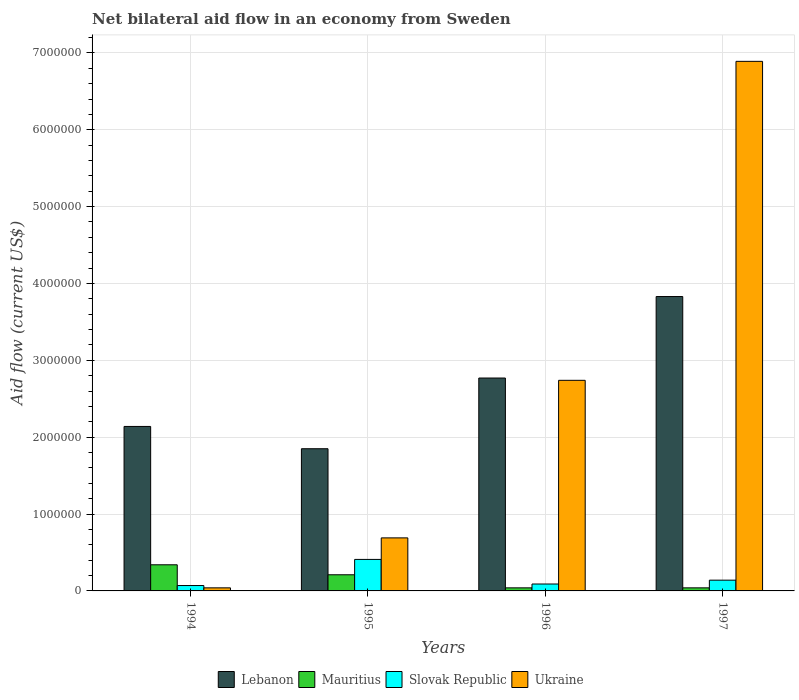Are the number of bars per tick equal to the number of legend labels?
Offer a terse response. Yes. What is the label of the 4th group of bars from the left?
Keep it short and to the point. 1997. In how many cases, is the number of bars for a given year not equal to the number of legend labels?
Your answer should be very brief. 0. Across all years, what is the maximum net bilateral aid flow in Slovak Republic?
Your answer should be very brief. 4.10e+05. In which year was the net bilateral aid flow in Ukraine maximum?
Give a very brief answer. 1997. In which year was the net bilateral aid flow in Mauritius minimum?
Provide a succinct answer. 1996. What is the total net bilateral aid flow in Lebanon in the graph?
Your response must be concise. 1.06e+07. What is the difference between the net bilateral aid flow in Slovak Republic in 1995 and that in 1996?
Your answer should be very brief. 3.20e+05. What is the difference between the net bilateral aid flow in Lebanon in 1994 and the net bilateral aid flow in Ukraine in 1995?
Provide a succinct answer. 1.45e+06. What is the average net bilateral aid flow in Slovak Republic per year?
Give a very brief answer. 1.78e+05. In the year 1994, what is the difference between the net bilateral aid flow in Lebanon and net bilateral aid flow in Slovak Republic?
Keep it short and to the point. 2.07e+06. In how many years, is the net bilateral aid flow in Mauritius greater than 5000000 US$?
Keep it short and to the point. 0. What is the ratio of the net bilateral aid flow in Lebanon in 1994 to that in 1997?
Keep it short and to the point. 0.56. Is the difference between the net bilateral aid flow in Lebanon in 1995 and 1997 greater than the difference between the net bilateral aid flow in Slovak Republic in 1995 and 1997?
Your answer should be very brief. No. In how many years, is the net bilateral aid flow in Lebanon greater than the average net bilateral aid flow in Lebanon taken over all years?
Provide a short and direct response. 2. Is it the case that in every year, the sum of the net bilateral aid flow in Lebanon and net bilateral aid flow in Ukraine is greater than the sum of net bilateral aid flow in Mauritius and net bilateral aid flow in Slovak Republic?
Give a very brief answer. Yes. What does the 4th bar from the left in 1994 represents?
Offer a very short reply. Ukraine. What does the 3rd bar from the right in 1997 represents?
Offer a terse response. Mauritius. Are all the bars in the graph horizontal?
Keep it short and to the point. No. How many years are there in the graph?
Provide a short and direct response. 4. What is the difference between two consecutive major ticks on the Y-axis?
Your response must be concise. 1.00e+06. Does the graph contain any zero values?
Give a very brief answer. No. Does the graph contain grids?
Your answer should be compact. Yes. How many legend labels are there?
Make the answer very short. 4. What is the title of the graph?
Your answer should be very brief. Net bilateral aid flow in an economy from Sweden. What is the Aid flow (current US$) in Lebanon in 1994?
Ensure brevity in your answer.  2.14e+06. What is the Aid flow (current US$) in Mauritius in 1994?
Provide a succinct answer. 3.40e+05. What is the Aid flow (current US$) in Slovak Republic in 1994?
Ensure brevity in your answer.  7.00e+04. What is the Aid flow (current US$) of Ukraine in 1994?
Offer a very short reply. 4.00e+04. What is the Aid flow (current US$) in Lebanon in 1995?
Your answer should be very brief. 1.85e+06. What is the Aid flow (current US$) of Mauritius in 1995?
Offer a terse response. 2.10e+05. What is the Aid flow (current US$) in Slovak Republic in 1995?
Offer a very short reply. 4.10e+05. What is the Aid flow (current US$) of Ukraine in 1995?
Make the answer very short. 6.90e+05. What is the Aid flow (current US$) in Lebanon in 1996?
Give a very brief answer. 2.77e+06. What is the Aid flow (current US$) in Mauritius in 1996?
Ensure brevity in your answer.  4.00e+04. What is the Aid flow (current US$) of Slovak Republic in 1996?
Offer a very short reply. 9.00e+04. What is the Aid flow (current US$) in Ukraine in 1996?
Offer a very short reply. 2.74e+06. What is the Aid flow (current US$) of Lebanon in 1997?
Make the answer very short. 3.83e+06. What is the Aid flow (current US$) in Slovak Republic in 1997?
Provide a succinct answer. 1.40e+05. What is the Aid flow (current US$) in Ukraine in 1997?
Your answer should be very brief. 6.89e+06. Across all years, what is the maximum Aid flow (current US$) of Lebanon?
Provide a short and direct response. 3.83e+06. Across all years, what is the maximum Aid flow (current US$) in Mauritius?
Give a very brief answer. 3.40e+05. Across all years, what is the maximum Aid flow (current US$) of Ukraine?
Your response must be concise. 6.89e+06. Across all years, what is the minimum Aid flow (current US$) of Lebanon?
Offer a terse response. 1.85e+06. Across all years, what is the minimum Aid flow (current US$) in Mauritius?
Make the answer very short. 4.00e+04. Across all years, what is the minimum Aid flow (current US$) of Ukraine?
Ensure brevity in your answer.  4.00e+04. What is the total Aid flow (current US$) of Lebanon in the graph?
Your answer should be very brief. 1.06e+07. What is the total Aid flow (current US$) of Mauritius in the graph?
Your response must be concise. 6.30e+05. What is the total Aid flow (current US$) of Slovak Republic in the graph?
Keep it short and to the point. 7.10e+05. What is the total Aid flow (current US$) of Ukraine in the graph?
Offer a very short reply. 1.04e+07. What is the difference between the Aid flow (current US$) in Lebanon in 1994 and that in 1995?
Keep it short and to the point. 2.90e+05. What is the difference between the Aid flow (current US$) of Slovak Republic in 1994 and that in 1995?
Your response must be concise. -3.40e+05. What is the difference between the Aid flow (current US$) of Ukraine in 1994 and that in 1995?
Offer a terse response. -6.50e+05. What is the difference between the Aid flow (current US$) in Lebanon in 1994 and that in 1996?
Provide a succinct answer. -6.30e+05. What is the difference between the Aid flow (current US$) in Ukraine in 1994 and that in 1996?
Ensure brevity in your answer.  -2.70e+06. What is the difference between the Aid flow (current US$) in Lebanon in 1994 and that in 1997?
Give a very brief answer. -1.69e+06. What is the difference between the Aid flow (current US$) of Ukraine in 1994 and that in 1997?
Offer a terse response. -6.85e+06. What is the difference between the Aid flow (current US$) in Lebanon in 1995 and that in 1996?
Make the answer very short. -9.20e+05. What is the difference between the Aid flow (current US$) of Slovak Republic in 1995 and that in 1996?
Make the answer very short. 3.20e+05. What is the difference between the Aid flow (current US$) in Ukraine in 1995 and that in 1996?
Provide a short and direct response. -2.05e+06. What is the difference between the Aid flow (current US$) of Lebanon in 1995 and that in 1997?
Offer a very short reply. -1.98e+06. What is the difference between the Aid flow (current US$) of Ukraine in 1995 and that in 1997?
Give a very brief answer. -6.20e+06. What is the difference between the Aid flow (current US$) in Lebanon in 1996 and that in 1997?
Keep it short and to the point. -1.06e+06. What is the difference between the Aid flow (current US$) in Ukraine in 1996 and that in 1997?
Offer a very short reply. -4.15e+06. What is the difference between the Aid flow (current US$) of Lebanon in 1994 and the Aid flow (current US$) of Mauritius in 1995?
Offer a very short reply. 1.93e+06. What is the difference between the Aid flow (current US$) of Lebanon in 1994 and the Aid flow (current US$) of Slovak Republic in 1995?
Your answer should be very brief. 1.73e+06. What is the difference between the Aid flow (current US$) of Lebanon in 1994 and the Aid flow (current US$) of Ukraine in 1995?
Give a very brief answer. 1.45e+06. What is the difference between the Aid flow (current US$) of Mauritius in 1994 and the Aid flow (current US$) of Ukraine in 1995?
Offer a terse response. -3.50e+05. What is the difference between the Aid flow (current US$) in Slovak Republic in 1994 and the Aid flow (current US$) in Ukraine in 1995?
Your answer should be very brief. -6.20e+05. What is the difference between the Aid flow (current US$) in Lebanon in 1994 and the Aid flow (current US$) in Mauritius in 1996?
Keep it short and to the point. 2.10e+06. What is the difference between the Aid flow (current US$) of Lebanon in 1994 and the Aid flow (current US$) of Slovak Republic in 1996?
Offer a very short reply. 2.05e+06. What is the difference between the Aid flow (current US$) of Lebanon in 1994 and the Aid flow (current US$) of Ukraine in 1996?
Your answer should be compact. -6.00e+05. What is the difference between the Aid flow (current US$) of Mauritius in 1994 and the Aid flow (current US$) of Ukraine in 1996?
Provide a short and direct response. -2.40e+06. What is the difference between the Aid flow (current US$) of Slovak Republic in 1994 and the Aid flow (current US$) of Ukraine in 1996?
Provide a succinct answer. -2.67e+06. What is the difference between the Aid flow (current US$) of Lebanon in 1994 and the Aid flow (current US$) of Mauritius in 1997?
Offer a very short reply. 2.10e+06. What is the difference between the Aid flow (current US$) of Lebanon in 1994 and the Aid flow (current US$) of Ukraine in 1997?
Offer a very short reply. -4.75e+06. What is the difference between the Aid flow (current US$) of Mauritius in 1994 and the Aid flow (current US$) of Slovak Republic in 1997?
Your answer should be compact. 2.00e+05. What is the difference between the Aid flow (current US$) in Mauritius in 1994 and the Aid flow (current US$) in Ukraine in 1997?
Offer a very short reply. -6.55e+06. What is the difference between the Aid flow (current US$) in Slovak Republic in 1994 and the Aid flow (current US$) in Ukraine in 1997?
Give a very brief answer. -6.82e+06. What is the difference between the Aid flow (current US$) of Lebanon in 1995 and the Aid flow (current US$) of Mauritius in 1996?
Your response must be concise. 1.81e+06. What is the difference between the Aid flow (current US$) in Lebanon in 1995 and the Aid flow (current US$) in Slovak Republic in 1996?
Provide a short and direct response. 1.76e+06. What is the difference between the Aid flow (current US$) in Lebanon in 1995 and the Aid flow (current US$) in Ukraine in 1996?
Offer a terse response. -8.90e+05. What is the difference between the Aid flow (current US$) in Mauritius in 1995 and the Aid flow (current US$) in Ukraine in 1996?
Your answer should be very brief. -2.53e+06. What is the difference between the Aid flow (current US$) of Slovak Republic in 1995 and the Aid flow (current US$) of Ukraine in 1996?
Offer a very short reply. -2.33e+06. What is the difference between the Aid flow (current US$) of Lebanon in 1995 and the Aid flow (current US$) of Mauritius in 1997?
Provide a succinct answer. 1.81e+06. What is the difference between the Aid flow (current US$) in Lebanon in 1995 and the Aid flow (current US$) in Slovak Republic in 1997?
Ensure brevity in your answer.  1.71e+06. What is the difference between the Aid flow (current US$) in Lebanon in 1995 and the Aid flow (current US$) in Ukraine in 1997?
Keep it short and to the point. -5.04e+06. What is the difference between the Aid flow (current US$) in Mauritius in 1995 and the Aid flow (current US$) in Slovak Republic in 1997?
Your response must be concise. 7.00e+04. What is the difference between the Aid flow (current US$) in Mauritius in 1995 and the Aid flow (current US$) in Ukraine in 1997?
Provide a short and direct response. -6.68e+06. What is the difference between the Aid flow (current US$) in Slovak Republic in 1995 and the Aid flow (current US$) in Ukraine in 1997?
Your answer should be very brief. -6.48e+06. What is the difference between the Aid flow (current US$) in Lebanon in 1996 and the Aid flow (current US$) in Mauritius in 1997?
Your answer should be compact. 2.73e+06. What is the difference between the Aid flow (current US$) in Lebanon in 1996 and the Aid flow (current US$) in Slovak Republic in 1997?
Keep it short and to the point. 2.63e+06. What is the difference between the Aid flow (current US$) of Lebanon in 1996 and the Aid flow (current US$) of Ukraine in 1997?
Ensure brevity in your answer.  -4.12e+06. What is the difference between the Aid flow (current US$) of Mauritius in 1996 and the Aid flow (current US$) of Slovak Republic in 1997?
Your answer should be compact. -1.00e+05. What is the difference between the Aid flow (current US$) of Mauritius in 1996 and the Aid flow (current US$) of Ukraine in 1997?
Your answer should be very brief. -6.85e+06. What is the difference between the Aid flow (current US$) of Slovak Republic in 1996 and the Aid flow (current US$) of Ukraine in 1997?
Your response must be concise. -6.80e+06. What is the average Aid flow (current US$) of Lebanon per year?
Offer a very short reply. 2.65e+06. What is the average Aid flow (current US$) in Mauritius per year?
Provide a succinct answer. 1.58e+05. What is the average Aid flow (current US$) in Slovak Republic per year?
Give a very brief answer. 1.78e+05. What is the average Aid flow (current US$) in Ukraine per year?
Your answer should be very brief. 2.59e+06. In the year 1994, what is the difference between the Aid flow (current US$) in Lebanon and Aid flow (current US$) in Mauritius?
Provide a short and direct response. 1.80e+06. In the year 1994, what is the difference between the Aid flow (current US$) in Lebanon and Aid flow (current US$) in Slovak Republic?
Make the answer very short. 2.07e+06. In the year 1994, what is the difference between the Aid flow (current US$) in Lebanon and Aid flow (current US$) in Ukraine?
Ensure brevity in your answer.  2.10e+06. In the year 1994, what is the difference between the Aid flow (current US$) of Mauritius and Aid flow (current US$) of Slovak Republic?
Make the answer very short. 2.70e+05. In the year 1994, what is the difference between the Aid flow (current US$) in Mauritius and Aid flow (current US$) in Ukraine?
Your response must be concise. 3.00e+05. In the year 1995, what is the difference between the Aid flow (current US$) of Lebanon and Aid flow (current US$) of Mauritius?
Offer a very short reply. 1.64e+06. In the year 1995, what is the difference between the Aid flow (current US$) of Lebanon and Aid flow (current US$) of Slovak Republic?
Provide a succinct answer. 1.44e+06. In the year 1995, what is the difference between the Aid flow (current US$) of Lebanon and Aid flow (current US$) of Ukraine?
Provide a succinct answer. 1.16e+06. In the year 1995, what is the difference between the Aid flow (current US$) of Mauritius and Aid flow (current US$) of Ukraine?
Ensure brevity in your answer.  -4.80e+05. In the year 1995, what is the difference between the Aid flow (current US$) of Slovak Republic and Aid flow (current US$) of Ukraine?
Give a very brief answer. -2.80e+05. In the year 1996, what is the difference between the Aid flow (current US$) of Lebanon and Aid flow (current US$) of Mauritius?
Your response must be concise. 2.73e+06. In the year 1996, what is the difference between the Aid flow (current US$) of Lebanon and Aid flow (current US$) of Slovak Republic?
Keep it short and to the point. 2.68e+06. In the year 1996, what is the difference between the Aid flow (current US$) in Mauritius and Aid flow (current US$) in Slovak Republic?
Provide a succinct answer. -5.00e+04. In the year 1996, what is the difference between the Aid flow (current US$) in Mauritius and Aid flow (current US$) in Ukraine?
Provide a succinct answer. -2.70e+06. In the year 1996, what is the difference between the Aid flow (current US$) of Slovak Republic and Aid flow (current US$) of Ukraine?
Offer a very short reply. -2.65e+06. In the year 1997, what is the difference between the Aid flow (current US$) in Lebanon and Aid flow (current US$) in Mauritius?
Ensure brevity in your answer.  3.79e+06. In the year 1997, what is the difference between the Aid flow (current US$) in Lebanon and Aid flow (current US$) in Slovak Republic?
Provide a short and direct response. 3.69e+06. In the year 1997, what is the difference between the Aid flow (current US$) of Lebanon and Aid flow (current US$) of Ukraine?
Your answer should be very brief. -3.06e+06. In the year 1997, what is the difference between the Aid flow (current US$) in Mauritius and Aid flow (current US$) in Ukraine?
Your answer should be compact. -6.85e+06. In the year 1997, what is the difference between the Aid flow (current US$) of Slovak Republic and Aid flow (current US$) of Ukraine?
Give a very brief answer. -6.75e+06. What is the ratio of the Aid flow (current US$) in Lebanon in 1994 to that in 1995?
Offer a terse response. 1.16. What is the ratio of the Aid flow (current US$) in Mauritius in 1994 to that in 1995?
Keep it short and to the point. 1.62. What is the ratio of the Aid flow (current US$) in Slovak Republic in 1994 to that in 1995?
Your answer should be compact. 0.17. What is the ratio of the Aid flow (current US$) of Ukraine in 1994 to that in 1995?
Your answer should be very brief. 0.06. What is the ratio of the Aid flow (current US$) in Lebanon in 1994 to that in 1996?
Your answer should be very brief. 0.77. What is the ratio of the Aid flow (current US$) in Slovak Republic in 1994 to that in 1996?
Provide a succinct answer. 0.78. What is the ratio of the Aid flow (current US$) of Ukraine in 1994 to that in 1996?
Provide a short and direct response. 0.01. What is the ratio of the Aid flow (current US$) in Lebanon in 1994 to that in 1997?
Give a very brief answer. 0.56. What is the ratio of the Aid flow (current US$) of Mauritius in 1994 to that in 1997?
Your answer should be compact. 8.5. What is the ratio of the Aid flow (current US$) of Ukraine in 1994 to that in 1997?
Provide a short and direct response. 0.01. What is the ratio of the Aid flow (current US$) in Lebanon in 1995 to that in 1996?
Your response must be concise. 0.67. What is the ratio of the Aid flow (current US$) in Mauritius in 1995 to that in 1996?
Provide a short and direct response. 5.25. What is the ratio of the Aid flow (current US$) of Slovak Republic in 1995 to that in 1996?
Ensure brevity in your answer.  4.56. What is the ratio of the Aid flow (current US$) of Ukraine in 1995 to that in 1996?
Make the answer very short. 0.25. What is the ratio of the Aid flow (current US$) of Lebanon in 1995 to that in 1997?
Provide a succinct answer. 0.48. What is the ratio of the Aid flow (current US$) in Mauritius in 1995 to that in 1997?
Give a very brief answer. 5.25. What is the ratio of the Aid flow (current US$) in Slovak Republic in 1995 to that in 1997?
Provide a succinct answer. 2.93. What is the ratio of the Aid flow (current US$) of Ukraine in 1995 to that in 1997?
Offer a terse response. 0.1. What is the ratio of the Aid flow (current US$) of Lebanon in 1996 to that in 1997?
Your response must be concise. 0.72. What is the ratio of the Aid flow (current US$) in Slovak Republic in 1996 to that in 1997?
Your answer should be compact. 0.64. What is the ratio of the Aid flow (current US$) of Ukraine in 1996 to that in 1997?
Provide a short and direct response. 0.4. What is the difference between the highest and the second highest Aid flow (current US$) in Lebanon?
Provide a short and direct response. 1.06e+06. What is the difference between the highest and the second highest Aid flow (current US$) of Slovak Republic?
Your response must be concise. 2.70e+05. What is the difference between the highest and the second highest Aid flow (current US$) in Ukraine?
Ensure brevity in your answer.  4.15e+06. What is the difference between the highest and the lowest Aid flow (current US$) in Lebanon?
Your response must be concise. 1.98e+06. What is the difference between the highest and the lowest Aid flow (current US$) in Slovak Republic?
Your answer should be very brief. 3.40e+05. What is the difference between the highest and the lowest Aid flow (current US$) of Ukraine?
Ensure brevity in your answer.  6.85e+06. 